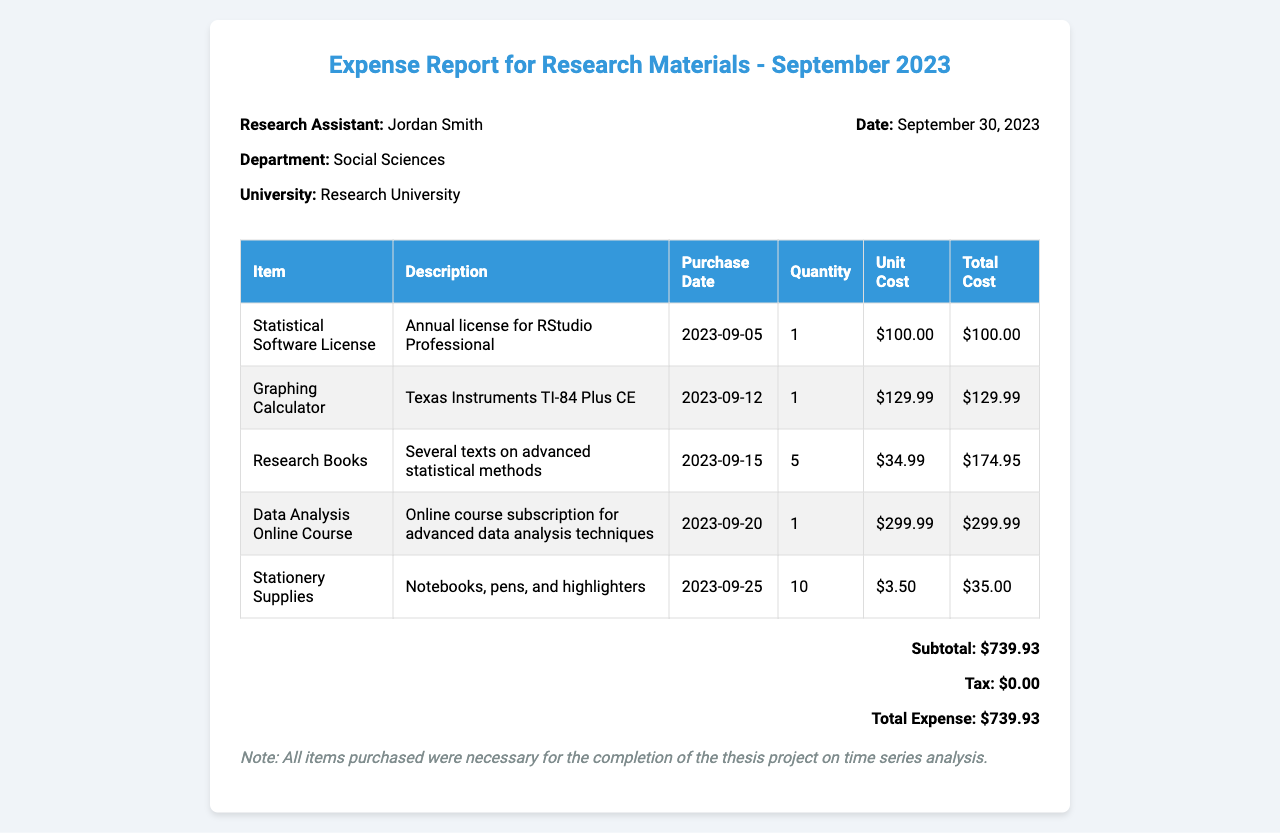what is the research assistant's name? The document clearly states the name of the research assistant as Jordan Smith.
Answer: Jordan Smith what is the total expense amount? The total expense is listed in the document under the total expense section, which is $739.93.
Answer: $739.93 how many research books were purchased? The quantity of research books purchased is mentioned in the itemized list, which states 5 were bought.
Answer: 5 what date was the statistical software license purchased? The document specifies that the statistical software license was purchased on September 5, 2023.
Answer: September 5, 2023 what is the subtotal before tax? The subtotal is provided in the totals section of the document, which is $739.93.
Answer: $739.93 which item has the highest unit cost? Analyzing the itemized costs reveals that the Data Analysis Online Course has the highest unit cost at $299.99.
Answer: Data Analysis Online Course how many stationery supplies were bought? The quantity listed for stationery supplies indicates that 10 items were purchased.
Answer: 10 what is the tax amount on the total expense? The document indicates that the tax amount is $0.00 in the totals section.
Answer: $0.00 what were the stationery supplies? The description of the stationery supplies states they are notebooks, pens, and highlighters.
Answer: Notebooks, pens, and highlighters 